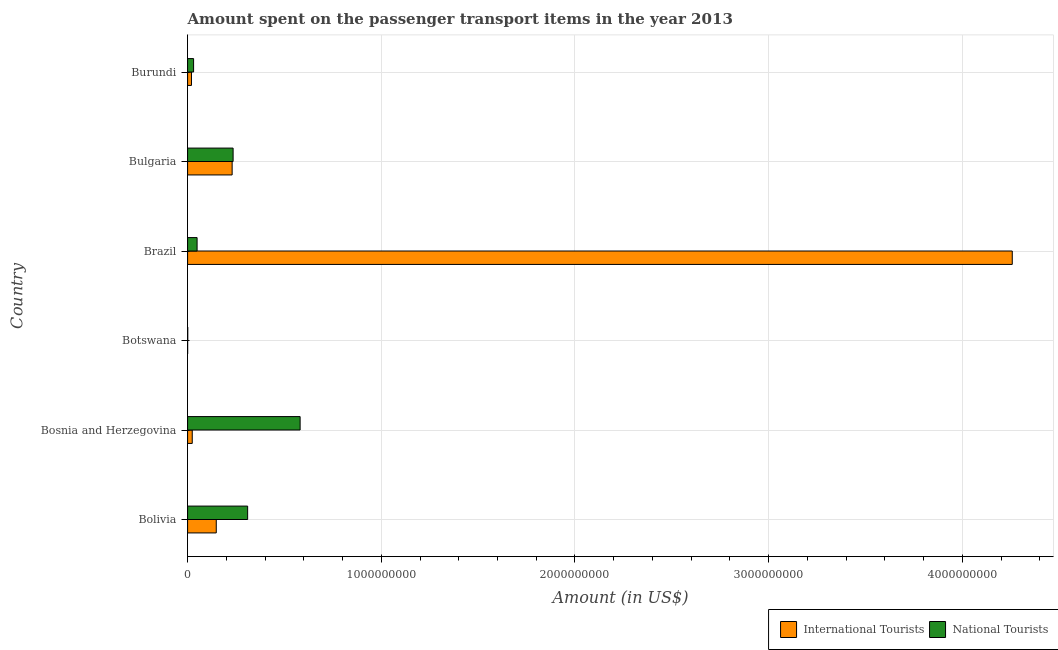How many different coloured bars are there?
Give a very brief answer. 2. How many bars are there on the 4th tick from the top?
Offer a terse response. 2. How many bars are there on the 3rd tick from the bottom?
Your answer should be very brief. 2. What is the amount spent on transport items of international tourists in Botswana?
Your answer should be compact. 2.00e+05. Across all countries, what is the maximum amount spent on transport items of national tourists?
Ensure brevity in your answer.  5.81e+08. Across all countries, what is the minimum amount spent on transport items of national tourists?
Ensure brevity in your answer.  8.00e+05. In which country was the amount spent on transport items of national tourists minimum?
Offer a very short reply. Botswana. What is the total amount spent on transport items of national tourists in the graph?
Your response must be concise. 1.21e+09. What is the difference between the amount spent on transport items of national tourists in Botswana and that in Burundi?
Provide a short and direct response. -3.02e+07. What is the difference between the amount spent on transport items of national tourists in Burundi and the amount spent on transport items of international tourists in Botswana?
Your response must be concise. 3.08e+07. What is the average amount spent on transport items of international tourists per country?
Your response must be concise. 7.80e+08. What is the difference between the amount spent on transport items of national tourists and amount spent on transport items of international tourists in Bulgaria?
Your answer should be compact. 5.00e+06. In how many countries, is the amount spent on transport items of national tourists greater than 400000000 US$?
Ensure brevity in your answer.  1. Is the amount spent on transport items of national tourists in Bosnia and Herzegovina less than that in Brazil?
Give a very brief answer. No. What is the difference between the highest and the second highest amount spent on transport items of international tourists?
Your answer should be compact. 4.03e+09. What is the difference between the highest and the lowest amount spent on transport items of national tourists?
Provide a succinct answer. 5.80e+08. Is the sum of the amount spent on transport items of national tourists in Bosnia and Herzegovina and Brazil greater than the maximum amount spent on transport items of international tourists across all countries?
Provide a short and direct response. No. What does the 1st bar from the top in Burundi represents?
Ensure brevity in your answer.  National Tourists. What does the 1st bar from the bottom in Bulgaria represents?
Offer a very short reply. International Tourists. What is the difference between two consecutive major ticks on the X-axis?
Keep it short and to the point. 1.00e+09. Does the graph contain any zero values?
Offer a very short reply. No. Where does the legend appear in the graph?
Make the answer very short. Bottom right. What is the title of the graph?
Give a very brief answer. Amount spent on the passenger transport items in the year 2013. Does "Chemicals" appear as one of the legend labels in the graph?
Offer a terse response. No. What is the label or title of the Y-axis?
Provide a succinct answer. Country. What is the Amount (in US$) of International Tourists in Bolivia?
Your answer should be compact. 1.48e+08. What is the Amount (in US$) in National Tourists in Bolivia?
Keep it short and to the point. 3.10e+08. What is the Amount (in US$) in International Tourists in Bosnia and Herzegovina?
Keep it short and to the point. 2.40e+07. What is the Amount (in US$) of National Tourists in Bosnia and Herzegovina?
Keep it short and to the point. 5.81e+08. What is the Amount (in US$) of International Tourists in Brazil?
Your answer should be very brief. 4.26e+09. What is the Amount (in US$) in National Tourists in Brazil?
Give a very brief answer. 4.90e+07. What is the Amount (in US$) in International Tourists in Bulgaria?
Make the answer very short. 2.30e+08. What is the Amount (in US$) of National Tourists in Bulgaria?
Keep it short and to the point. 2.35e+08. What is the Amount (in US$) in National Tourists in Burundi?
Keep it short and to the point. 3.10e+07. Across all countries, what is the maximum Amount (in US$) of International Tourists?
Keep it short and to the point. 4.26e+09. Across all countries, what is the maximum Amount (in US$) in National Tourists?
Give a very brief answer. 5.81e+08. What is the total Amount (in US$) in International Tourists in the graph?
Your answer should be very brief. 4.68e+09. What is the total Amount (in US$) in National Tourists in the graph?
Your answer should be very brief. 1.21e+09. What is the difference between the Amount (in US$) of International Tourists in Bolivia and that in Bosnia and Herzegovina?
Keep it short and to the point. 1.24e+08. What is the difference between the Amount (in US$) of National Tourists in Bolivia and that in Bosnia and Herzegovina?
Provide a succinct answer. -2.71e+08. What is the difference between the Amount (in US$) in International Tourists in Bolivia and that in Botswana?
Give a very brief answer. 1.48e+08. What is the difference between the Amount (in US$) in National Tourists in Bolivia and that in Botswana?
Your answer should be very brief. 3.09e+08. What is the difference between the Amount (in US$) in International Tourists in Bolivia and that in Brazil?
Keep it short and to the point. -4.11e+09. What is the difference between the Amount (in US$) in National Tourists in Bolivia and that in Brazil?
Give a very brief answer. 2.61e+08. What is the difference between the Amount (in US$) of International Tourists in Bolivia and that in Bulgaria?
Provide a succinct answer. -8.20e+07. What is the difference between the Amount (in US$) in National Tourists in Bolivia and that in Bulgaria?
Provide a short and direct response. 7.50e+07. What is the difference between the Amount (in US$) in International Tourists in Bolivia and that in Burundi?
Offer a very short reply. 1.28e+08. What is the difference between the Amount (in US$) in National Tourists in Bolivia and that in Burundi?
Offer a terse response. 2.79e+08. What is the difference between the Amount (in US$) of International Tourists in Bosnia and Herzegovina and that in Botswana?
Give a very brief answer. 2.38e+07. What is the difference between the Amount (in US$) in National Tourists in Bosnia and Herzegovina and that in Botswana?
Give a very brief answer. 5.80e+08. What is the difference between the Amount (in US$) in International Tourists in Bosnia and Herzegovina and that in Brazil?
Provide a succinct answer. -4.23e+09. What is the difference between the Amount (in US$) in National Tourists in Bosnia and Herzegovina and that in Brazil?
Provide a short and direct response. 5.32e+08. What is the difference between the Amount (in US$) in International Tourists in Bosnia and Herzegovina and that in Bulgaria?
Offer a very short reply. -2.06e+08. What is the difference between the Amount (in US$) of National Tourists in Bosnia and Herzegovina and that in Bulgaria?
Provide a succinct answer. 3.46e+08. What is the difference between the Amount (in US$) of National Tourists in Bosnia and Herzegovina and that in Burundi?
Offer a very short reply. 5.50e+08. What is the difference between the Amount (in US$) of International Tourists in Botswana and that in Brazil?
Your response must be concise. -4.26e+09. What is the difference between the Amount (in US$) in National Tourists in Botswana and that in Brazil?
Provide a succinct answer. -4.82e+07. What is the difference between the Amount (in US$) of International Tourists in Botswana and that in Bulgaria?
Offer a very short reply. -2.30e+08. What is the difference between the Amount (in US$) in National Tourists in Botswana and that in Bulgaria?
Keep it short and to the point. -2.34e+08. What is the difference between the Amount (in US$) of International Tourists in Botswana and that in Burundi?
Give a very brief answer. -1.98e+07. What is the difference between the Amount (in US$) in National Tourists in Botswana and that in Burundi?
Ensure brevity in your answer.  -3.02e+07. What is the difference between the Amount (in US$) of International Tourists in Brazil and that in Bulgaria?
Keep it short and to the point. 4.03e+09. What is the difference between the Amount (in US$) in National Tourists in Brazil and that in Bulgaria?
Your answer should be compact. -1.86e+08. What is the difference between the Amount (in US$) of International Tourists in Brazil and that in Burundi?
Your answer should be very brief. 4.24e+09. What is the difference between the Amount (in US$) of National Tourists in Brazil and that in Burundi?
Your response must be concise. 1.80e+07. What is the difference between the Amount (in US$) in International Tourists in Bulgaria and that in Burundi?
Keep it short and to the point. 2.10e+08. What is the difference between the Amount (in US$) in National Tourists in Bulgaria and that in Burundi?
Your response must be concise. 2.04e+08. What is the difference between the Amount (in US$) in International Tourists in Bolivia and the Amount (in US$) in National Tourists in Bosnia and Herzegovina?
Offer a very short reply. -4.33e+08. What is the difference between the Amount (in US$) of International Tourists in Bolivia and the Amount (in US$) of National Tourists in Botswana?
Give a very brief answer. 1.47e+08. What is the difference between the Amount (in US$) of International Tourists in Bolivia and the Amount (in US$) of National Tourists in Brazil?
Your response must be concise. 9.90e+07. What is the difference between the Amount (in US$) of International Tourists in Bolivia and the Amount (in US$) of National Tourists in Bulgaria?
Keep it short and to the point. -8.70e+07. What is the difference between the Amount (in US$) in International Tourists in Bolivia and the Amount (in US$) in National Tourists in Burundi?
Keep it short and to the point. 1.17e+08. What is the difference between the Amount (in US$) in International Tourists in Bosnia and Herzegovina and the Amount (in US$) in National Tourists in Botswana?
Your response must be concise. 2.32e+07. What is the difference between the Amount (in US$) of International Tourists in Bosnia and Herzegovina and the Amount (in US$) of National Tourists in Brazil?
Provide a succinct answer. -2.50e+07. What is the difference between the Amount (in US$) in International Tourists in Bosnia and Herzegovina and the Amount (in US$) in National Tourists in Bulgaria?
Provide a succinct answer. -2.11e+08. What is the difference between the Amount (in US$) of International Tourists in Bosnia and Herzegovina and the Amount (in US$) of National Tourists in Burundi?
Your answer should be very brief. -7.00e+06. What is the difference between the Amount (in US$) in International Tourists in Botswana and the Amount (in US$) in National Tourists in Brazil?
Ensure brevity in your answer.  -4.88e+07. What is the difference between the Amount (in US$) in International Tourists in Botswana and the Amount (in US$) in National Tourists in Bulgaria?
Your answer should be compact. -2.35e+08. What is the difference between the Amount (in US$) of International Tourists in Botswana and the Amount (in US$) of National Tourists in Burundi?
Offer a terse response. -3.08e+07. What is the difference between the Amount (in US$) in International Tourists in Brazil and the Amount (in US$) in National Tourists in Bulgaria?
Provide a succinct answer. 4.02e+09. What is the difference between the Amount (in US$) in International Tourists in Brazil and the Amount (in US$) in National Tourists in Burundi?
Provide a short and direct response. 4.23e+09. What is the difference between the Amount (in US$) in International Tourists in Bulgaria and the Amount (in US$) in National Tourists in Burundi?
Make the answer very short. 1.99e+08. What is the average Amount (in US$) of International Tourists per country?
Keep it short and to the point. 7.80e+08. What is the average Amount (in US$) of National Tourists per country?
Offer a very short reply. 2.01e+08. What is the difference between the Amount (in US$) in International Tourists and Amount (in US$) in National Tourists in Bolivia?
Offer a terse response. -1.62e+08. What is the difference between the Amount (in US$) of International Tourists and Amount (in US$) of National Tourists in Bosnia and Herzegovina?
Your answer should be compact. -5.57e+08. What is the difference between the Amount (in US$) in International Tourists and Amount (in US$) in National Tourists in Botswana?
Offer a very short reply. -6.00e+05. What is the difference between the Amount (in US$) in International Tourists and Amount (in US$) in National Tourists in Brazil?
Make the answer very short. 4.21e+09. What is the difference between the Amount (in US$) of International Tourists and Amount (in US$) of National Tourists in Bulgaria?
Your answer should be very brief. -5.00e+06. What is the difference between the Amount (in US$) in International Tourists and Amount (in US$) in National Tourists in Burundi?
Keep it short and to the point. -1.10e+07. What is the ratio of the Amount (in US$) in International Tourists in Bolivia to that in Bosnia and Herzegovina?
Offer a terse response. 6.17. What is the ratio of the Amount (in US$) in National Tourists in Bolivia to that in Bosnia and Herzegovina?
Provide a short and direct response. 0.53. What is the ratio of the Amount (in US$) of International Tourists in Bolivia to that in Botswana?
Make the answer very short. 740. What is the ratio of the Amount (in US$) in National Tourists in Bolivia to that in Botswana?
Make the answer very short. 387.5. What is the ratio of the Amount (in US$) of International Tourists in Bolivia to that in Brazil?
Your answer should be very brief. 0.03. What is the ratio of the Amount (in US$) in National Tourists in Bolivia to that in Brazil?
Make the answer very short. 6.33. What is the ratio of the Amount (in US$) in International Tourists in Bolivia to that in Bulgaria?
Your response must be concise. 0.64. What is the ratio of the Amount (in US$) of National Tourists in Bolivia to that in Bulgaria?
Give a very brief answer. 1.32. What is the ratio of the Amount (in US$) in International Tourists in Bolivia to that in Burundi?
Keep it short and to the point. 7.4. What is the ratio of the Amount (in US$) in International Tourists in Bosnia and Herzegovina to that in Botswana?
Your answer should be compact. 120. What is the ratio of the Amount (in US$) of National Tourists in Bosnia and Herzegovina to that in Botswana?
Keep it short and to the point. 726.25. What is the ratio of the Amount (in US$) in International Tourists in Bosnia and Herzegovina to that in Brazil?
Give a very brief answer. 0.01. What is the ratio of the Amount (in US$) of National Tourists in Bosnia and Herzegovina to that in Brazil?
Give a very brief answer. 11.86. What is the ratio of the Amount (in US$) of International Tourists in Bosnia and Herzegovina to that in Bulgaria?
Your response must be concise. 0.1. What is the ratio of the Amount (in US$) in National Tourists in Bosnia and Herzegovina to that in Bulgaria?
Offer a very short reply. 2.47. What is the ratio of the Amount (in US$) in International Tourists in Bosnia and Herzegovina to that in Burundi?
Ensure brevity in your answer.  1.2. What is the ratio of the Amount (in US$) of National Tourists in Bosnia and Herzegovina to that in Burundi?
Ensure brevity in your answer.  18.74. What is the ratio of the Amount (in US$) in International Tourists in Botswana to that in Brazil?
Provide a succinct answer. 0. What is the ratio of the Amount (in US$) of National Tourists in Botswana to that in Brazil?
Your response must be concise. 0.02. What is the ratio of the Amount (in US$) of International Tourists in Botswana to that in Bulgaria?
Provide a succinct answer. 0. What is the ratio of the Amount (in US$) in National Tourists in Botswana to that in Bulgaria?
Offer a terse response. 0. What is the ratio of the Amount (in US$) of National Tourists in Botswana to that in Burundi?
Your answer should be compact. 0.03. What is the ratio of the Amount (in US$) of International Tourists in Brazil to that in Bulgaria?
Your answer should be compact. 18.51. What is the ratio of the Amount (in US$) in National Tourists in Brazil to that in Bulgaria?
Your response must be concise. 0.21. What is the ratio of the Amount (in US$) of International Tourists in Brazil to that in Burundi?
Make the answer very short. 212.9. What is the ratio of the Amount (in US$) of National Tourists in Brazil to that in Burundi?
Your response must be concise. 1.58. What is the ratio of the Amount (in US$) of National Tourists in Bulgaria to that in Burundi?
Your answer should be compact. 7.58. What is the difference between the highest and the second highest Amount (in US$) of International Tourists?
Your answer should be compact. 4.03e+09. What is the difference between the highest and the second highest Amount (in US$) in National Tourists?
Your answer should be very brief. 2.71e+08. What is the difference between the highest and the lowest Amount (in US$) in International Tourists?
Your answer should be compact. 4.26e+09. What is the difference between the highest and the lowest Amount (in US$) of National Tourists?
Keep it short and to the point. 5.80e+08. 